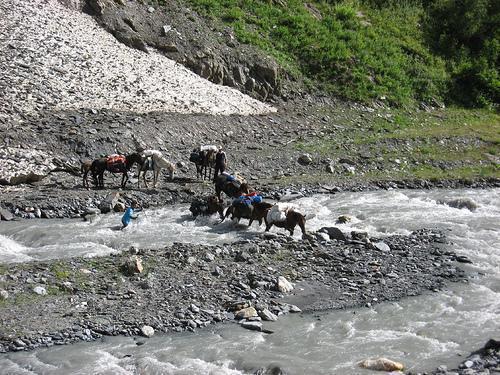How many people are shown?
Give a very brief answer. 2. 